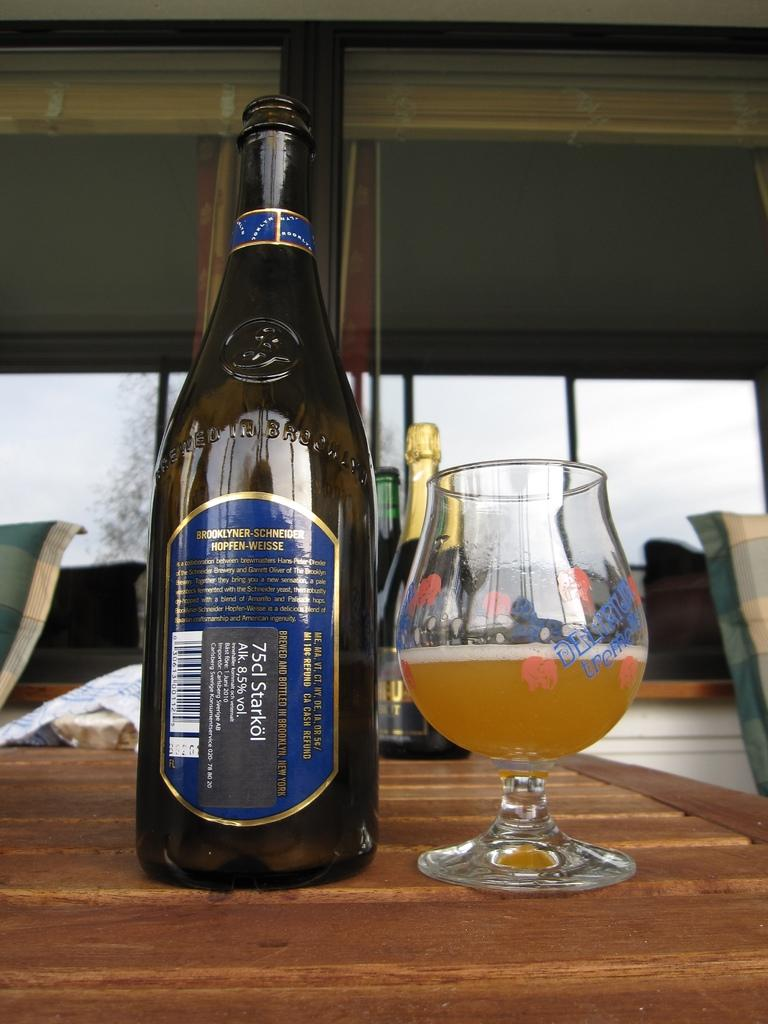What is the main subject of the image? The main subject of the image is a wine bottle with a label and a glass of wine. Where are the wine bottle and glass located? Both the wine bottle and glass are on a table. What can be seen in the background of the image? In the background of the image, there are multiple wine bottles, a chair, a building, a tree, and the sky. What health benefits can be gained from the list of ingredients on the wine bottle label? The image does not provide a list of ingredients on the wine bottle label, so it is not possible to determine any health benefits. 